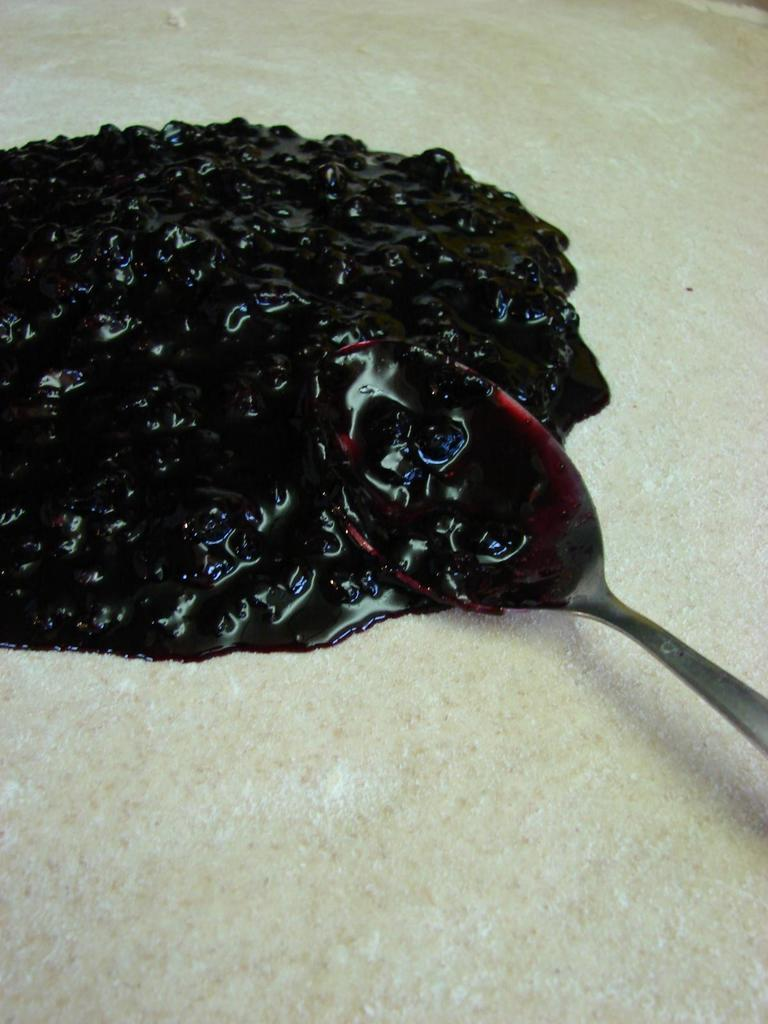What is the main subject of the image? The main subject of the image is dough. What object is present in the image that might be used for mixing or spreading? There is a spoon in the image. What is on top of the dough in the image? There is jam on the dough in the image. What type of porter is helping the beginner at the station in the image? There is no porter, beginner, or station present in the image; it only features dough, a spoon, and jam. 